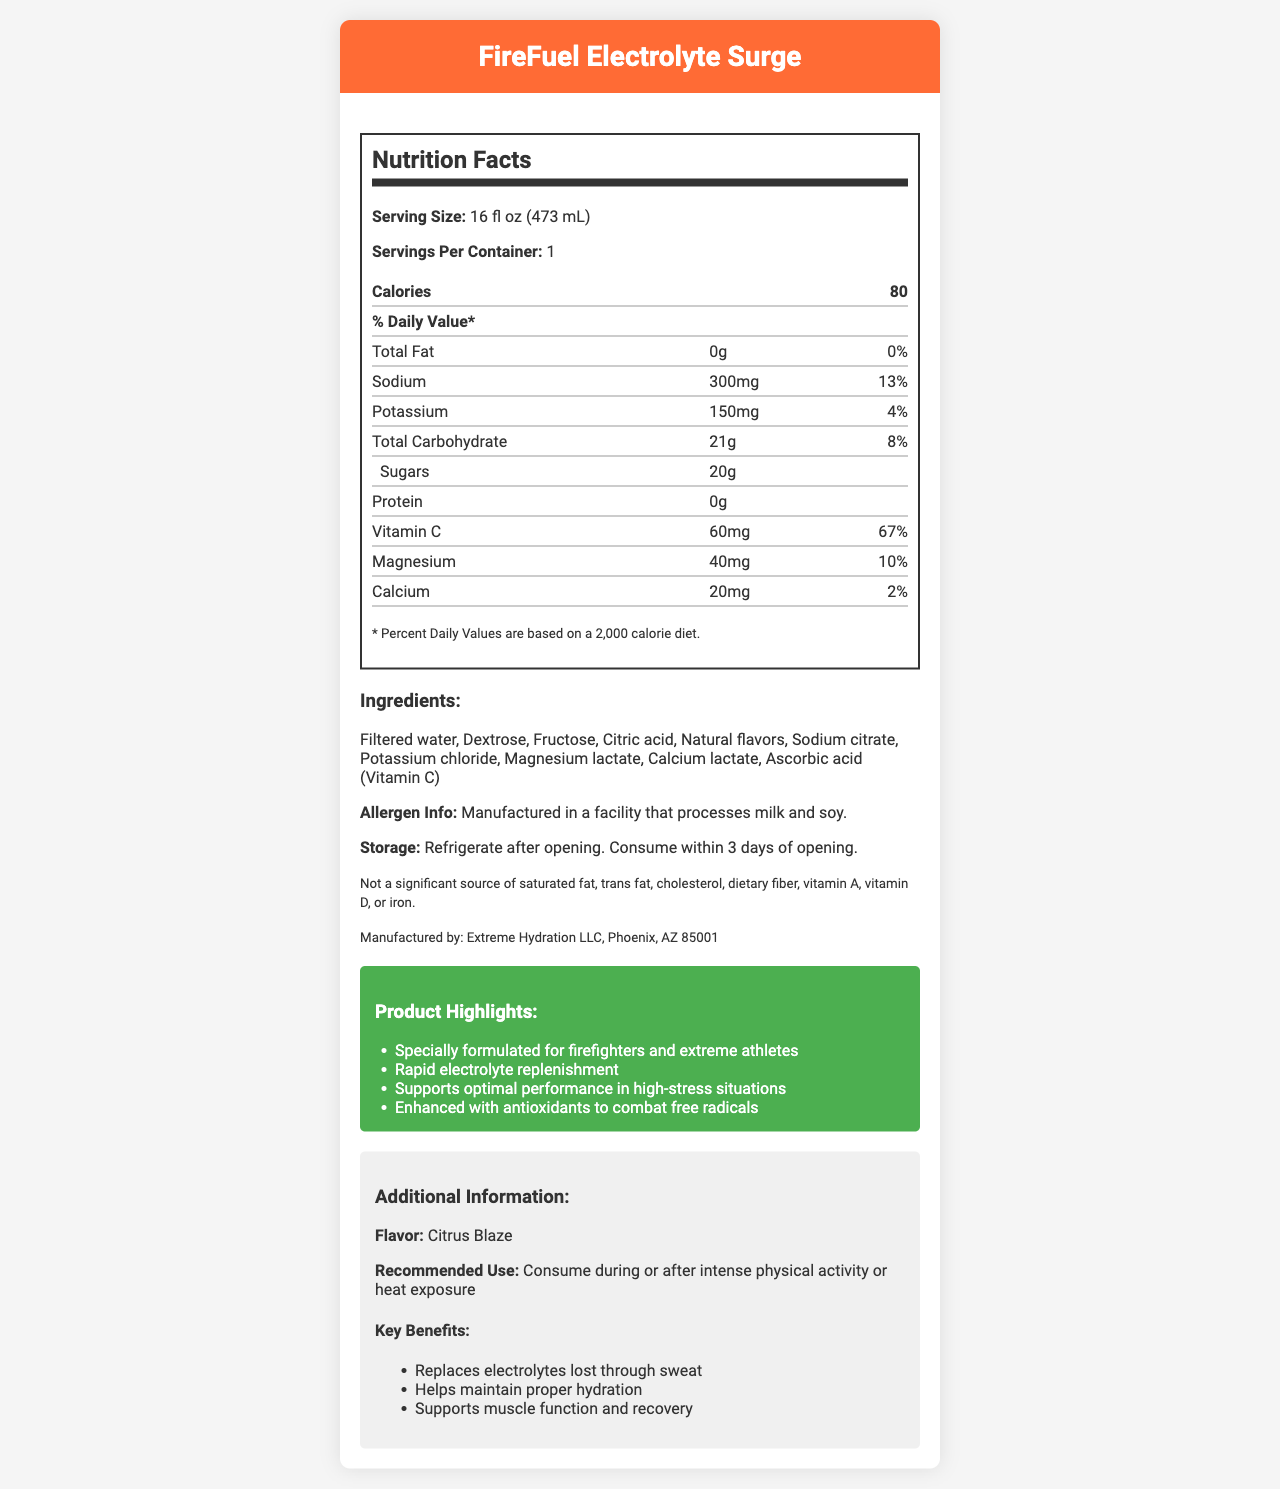what is the serving size of FireFuel Electrolyte Surge? The serving size is clearly listed at the top of the Nutrition Facts section.
Answer: 16 fl oz (473 mL) how many calories are in a single serving of this sports drink? The calories are mentioned directly below the serving size in the Nutrition Facts section.
Answer: 80 how much sodium does this sports drink contain? The amount of sodium is listed in the Nutrition Facts section next to "Sodium".
Answer: 300mg what percentage of the daily value of vitamin C does one serving provide? The daily value percentage for Vitamin C is listed next to its amount in the Nutrition Facts section.
Answer: 67% what type of athletes is this drink specially formulated for? This information is found in the Product Highlights section under marketing claims.
Answer: Firefighters and extreme athletes which of the following is not an ingredient in FireFuel Electrolyte Surge? A. Dextrose B. Fructose C. Acesulfame potassium D. Magnesium lactate The list of ingredients does not include Acesulfame potassium.
Answer: C. Acesulfame potassium which statement is correct about the consumption recommendation? I. Should be consumed before physical activity II. Should be consumed during or after intense physical activity III. Should be consumed during or after heat exposure The Recommended Use section states it should be consumed during or after intense physical activity or heat exposure.
Answer: II and III is this product a significant source of calcium? The disclaimer explicitly states it is not a significant source of calcium.
Answer: No does this drink contain any protein? The Nutrition Facts section indicates that the protein content is 0g.
Answer: No describe the main idea of the document. The document contains comprehensive information about the ingredients, nutritional content, and benefits of FireFuel Electrolyte Surge, alongside usage recommendations and marketing claims.
Answer: The document provides detailed Nutrition Facts, ingredients, allergen information, storage guidelines, product highlights, and additional information about FireFuel Electrolyte Surge – a specialized electrolyte-rich sports drink formulated for firefighters and extreme athletes. It emphasizes its benefits for hydration, electrolyte replenishment, and muscle recovery. what is the main source of carbohydrates in this drink? The document does not specify which ingredient is the primary source of carbohydrates.
Answer: Cannot be determined what is the total amount of sugars in FireFuel Electrolyte Surge? The total amount of sugars is listed in the Nutrition Facts section under "Sugars".
Answer: 20g who manufactures this sports drink? The manufacturer information is provided at the end of the Ingredients section.
Answer: Extreme Hydration LLC, Phoenix, AZ 85001 how much magnesium is in each serving and what percentage of the daily value does this represent? The Nutrition Facts section lists the amount of magnesium and its corresponding daily value percentage.
Answer: 40mg and 10% 